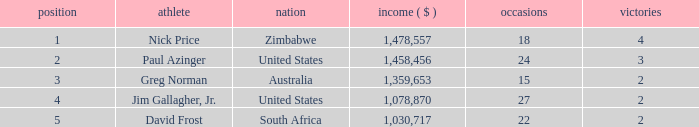How many events have earnings less than 1,030,717? 0.0. Could you parse the entire table as a dict? {'header': ['position', 'athlete', 'nation', 'income ( $ )', 'occasions', 'victories'], 'rows': [['1', 'Nick Price', 'Zimbabwe', '1,478,557', '18', '4'], ['2', 'Paul Azinger', 'United States', '1,458,456', '24', '3'], ['3', 'Greg Norman', 'Australia', '1,359,653', '15', '2'], ['4', 'Jim Gallagher, Jr.', 'United States', '1,078,870', '27', '2'], ['5', 'David Frost', 'South Africa', '1,030,717', '22', '2']]} 